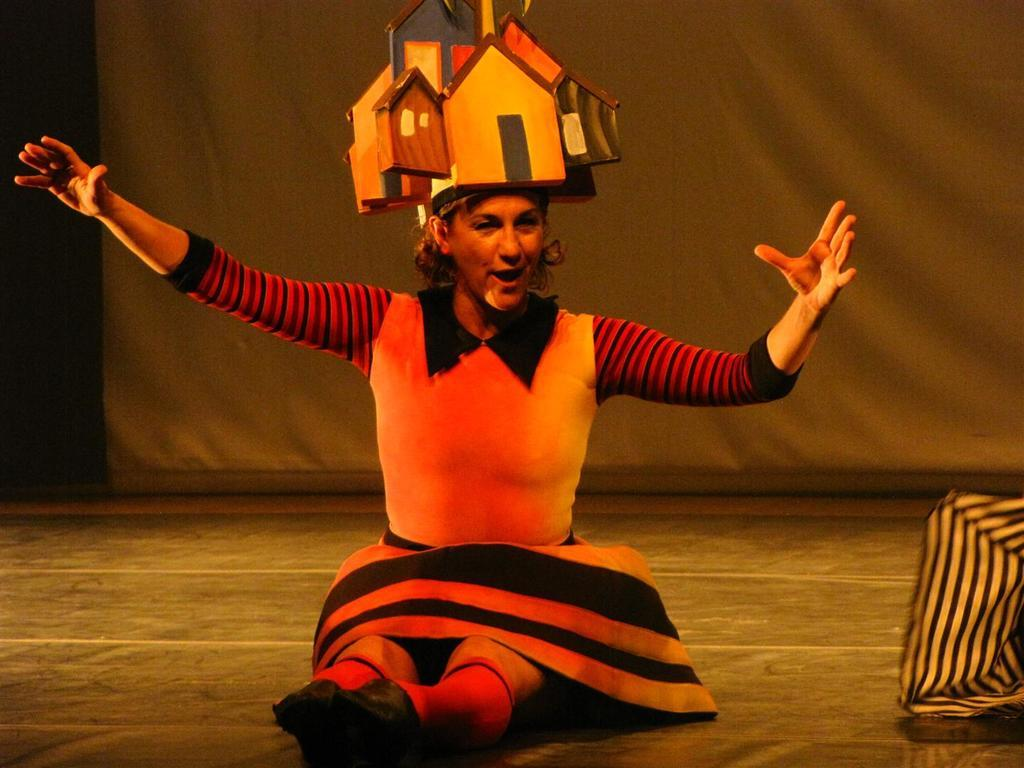Who is present in the image? There is a woman in the image. What is the woman wearing on her head? The woman is wearing something on her head. What is the woman's position in the image? The woman is sitting on the floor. What object can be seen beside the woman? There is an object beside the woman. What is visible behind the woman? There is a curtain behind the woman. What type of popcorn is the woman eating in the image? There is no popcorn present in the image, and the woman is not eating anything. What thrilling activity is the woman participating in the image? There is no thrilling activity depicted in the image; the woman is simply sitting on the floor. 